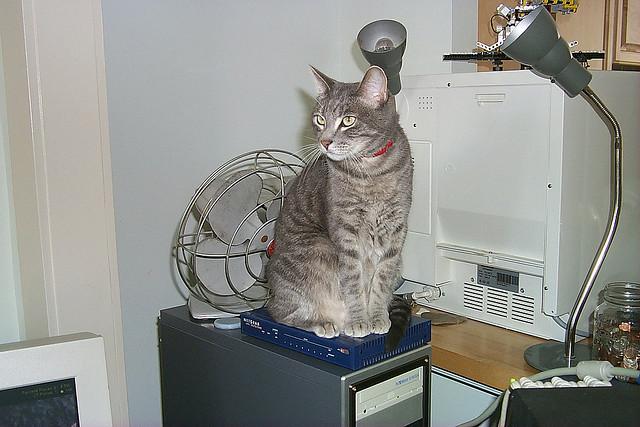What color is the cat?
Concise answer only. Gray. What color is the cat's collar?
Be succinct. Red. Is the fan going?
Write a very short answer. No. 